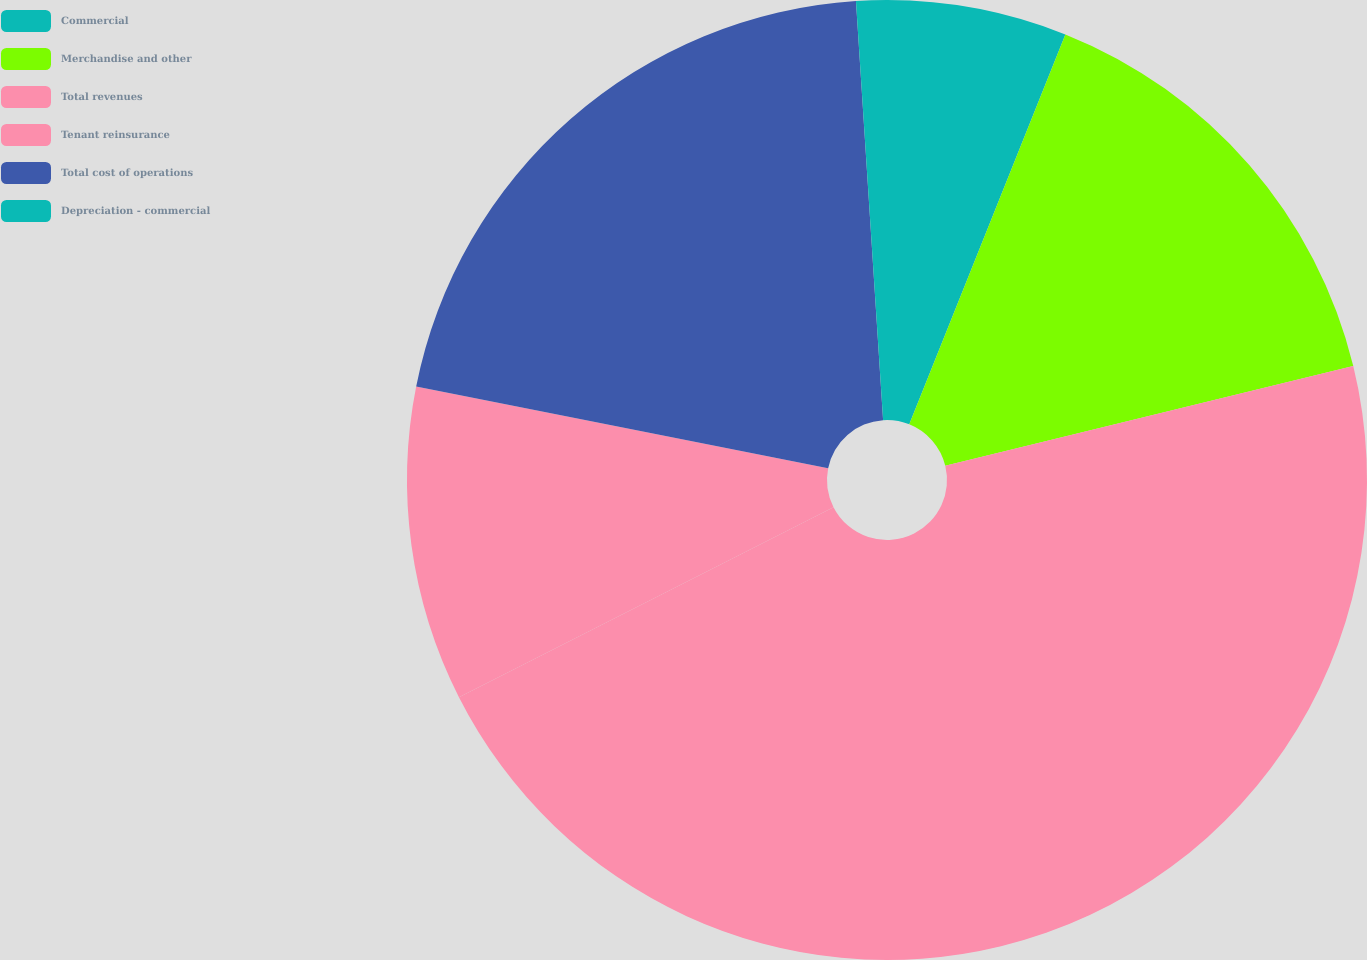<chart> <loc_0><loc_0><loc_500><loc_500><pie_chart><fcel>Commercial<fcel>Merchandise and other<fcel>Total revenues<fcel>Tenant reinsurance<fcel>Total cost of operations<fcel>Depreciation - commercial<nl><fcel>6.06%<fcel>15.12%<fcel>46.34%<fcel>10.59%<fcel>20.85%<fcel>1.03%<nl></chart> 